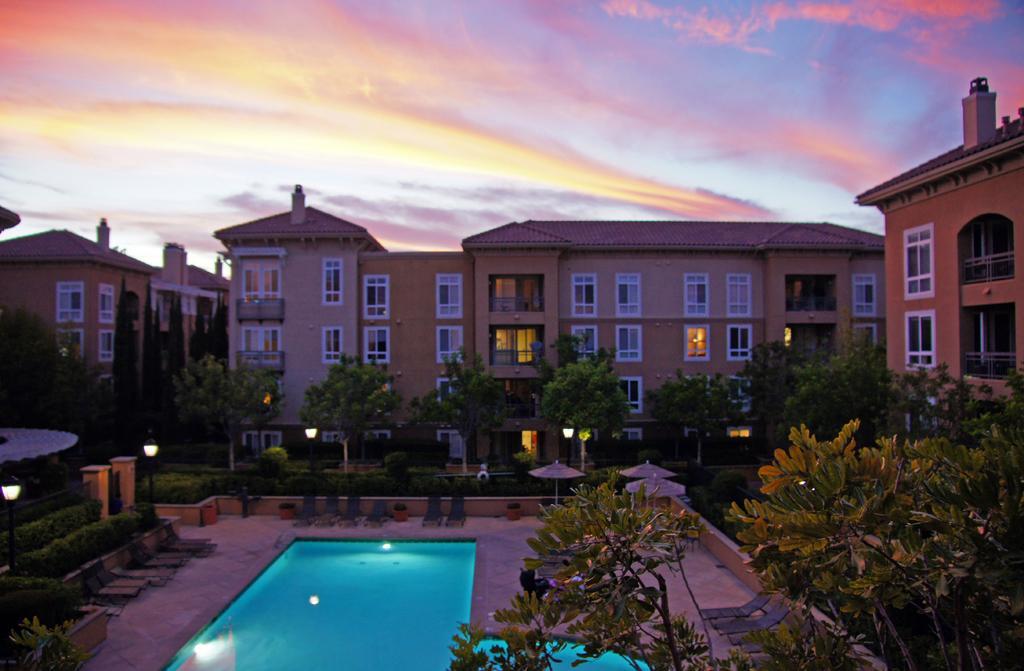In one or two sentences, can you explain what this image depicts? These are the buildings with the windows and lights. I can see a swimming pool with the water. These are the beach chairs. I can see the trees and bushes. I think these are the flower pots with plants. These are the kind of beach umbrellas. I can see the light poles. These are the clouds in the sky. 